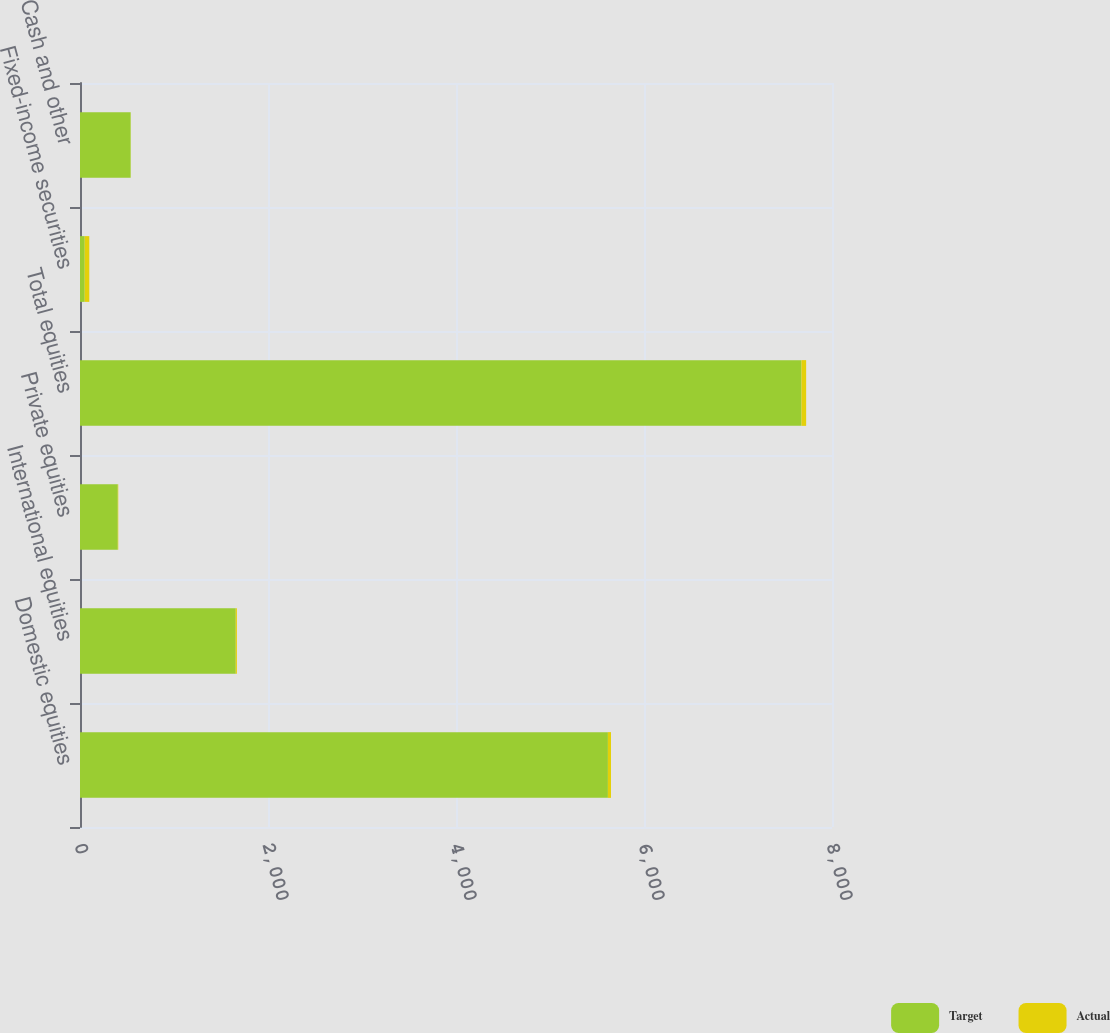<chart> <loc_0><loc_0><loc_500><loc_500><stacked_bar_chart><ecel><fcel>Domestic equities<fcel>International equities<fcel>Private equities<fcel>Total equities<fcel>Fixed-income securities<fcel>Cash and other<nl><fcel>Target<fcel>5616<fcel>1657<fcel>402<fcel>7675<fcel>50<fcel>539<nl><fcel>Actual<fcel>33<fcel>12<fcel>5<fcel>50<fcel>49<fcel>1<nl></chart> 